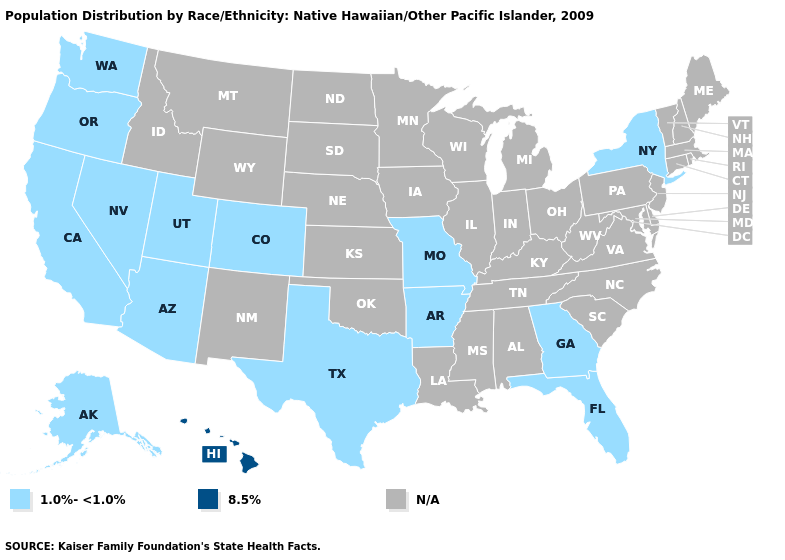What is the lowest value in states that border Wyoming?
Concise answer only. 1.0%-<1.0%. Name the states that have a value in the range 1.0%-<1.0%?
Give a very brief answer. Alaska, Arizona, Arkansas, California, Colorado, Florida, Georgia, Missouri, Nevada, New York, Oregon, Texas, Utah, Washington. Name the states that have a value in the range 8.5%?
Quick response, please. Hawaii. What is the value of North Carolina?
Short answer required. N/A. What is the highest value in the USA?
Concise answer only. 8.5%. Which states hav the highest value in the South?
Be succinct. Arkansas, Florida, Georgia, Texas. Does the map have missing data?
Concise answer only. Yes. Name the states that have a value in the range N/A?
Give a very brief answer. Alabama, Connecticut, Delaware, Idaho, Illinois, Indiana, Iowa, Kansas, Kentucky, Louisiana, Maine, Maryland, Massachusetts, Michigan, Minnesota, Mississippi, Montana, Nebraska, New Hampshire, New Jersey, New Mexico, North Carolina, North Dakota, Ohio, Oklahoma, Pennsylvania, Rhode Island, South Carolina, South Dakota, Tennessee, Vermont, Virginia, West Virginia, Wisconsin, Wyoming. What is the lowest value in states that border Nevada?
Keep it brief. 1.0%-<1.0%. Does the first symbol in the legend represent the smallest category?
Give a very brief answer. Yes. 